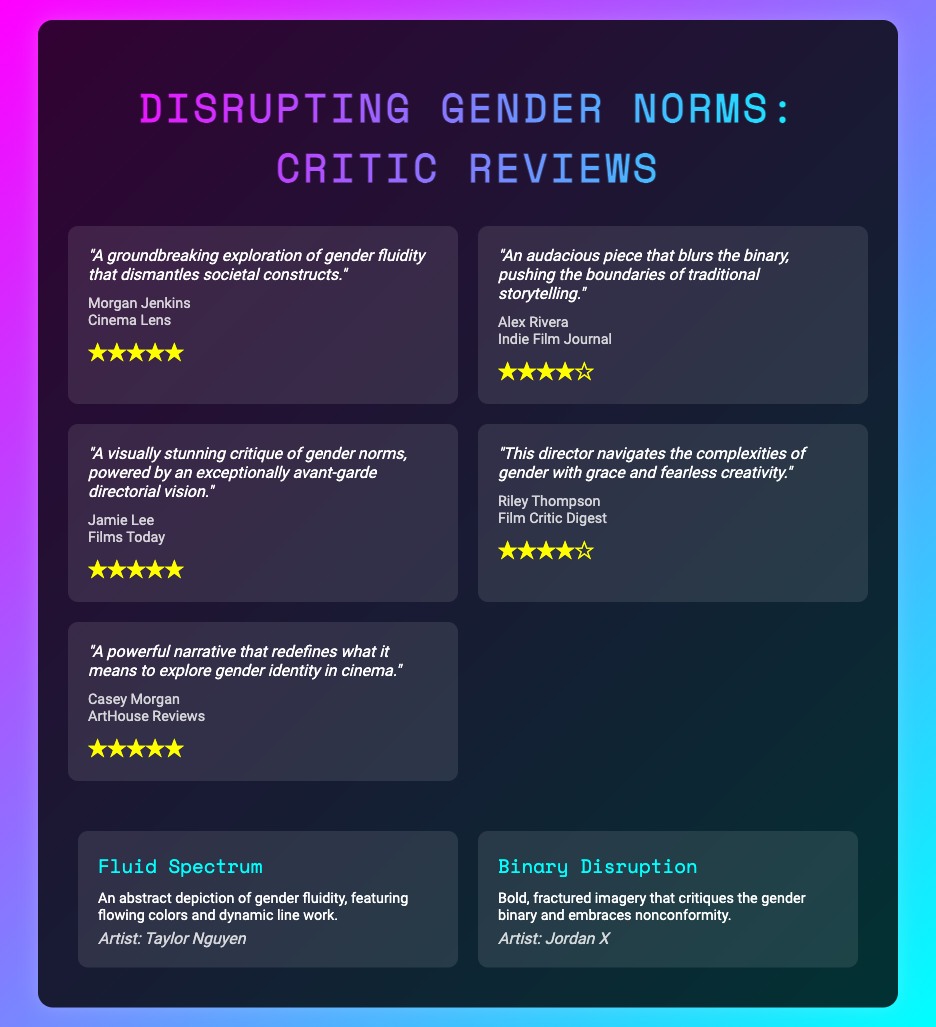What is the title of the document? The title appears prominently at the top of the document and is "Disrupting Gender Norms: Critic Reviews."
Answer: Disrupting Gender Norms: Critic Reviews How many reviews are included in the document? The document contains a total of five reviews, each listed separately.
Answer: 5 Who wrote the quote "A visual stunning critique of gender norms"? This specific quote is attributed to Jamie Lee, as noted in the review section.
Answer: Jamie Lee What rating did Casey Morgan give? The rating assigned by Casey Morgan in their review is visible in the ratings section.
Answer: ★★★★★ What is the title of the first art piece? The title of the first art piece is listed in the artwork section as "Fluid Spectrum."
Answer: Fluid Spectrum What publication featured Morgan Jenkins' review? Morgan Jenkins' review is listed under "Cinema Lens" as the publication name.
Answer: Cinema Lens What do the art descriptions primarily focus on? The descriptions of the art pieces emphasize themes related to gender fluidity and nonconformity.
Answer: Gender fluidity and nonconformity Which critic gave a four-star rating? Alex Rivera and Riley Thompson both provided four-star ratings in their reviews.
Answer: Alex Rivera, Riley Thompson 